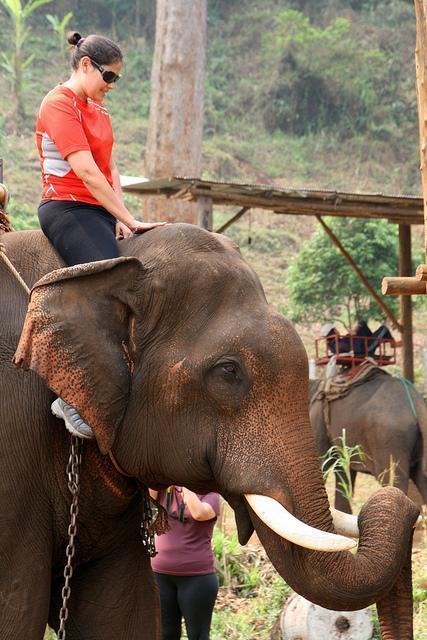Why is there a chain on the elephant?
Pick the correct solution from the four options below to address the question.
Options: It's dangerous, it's injured, it's property, it's stylish. It's property. 